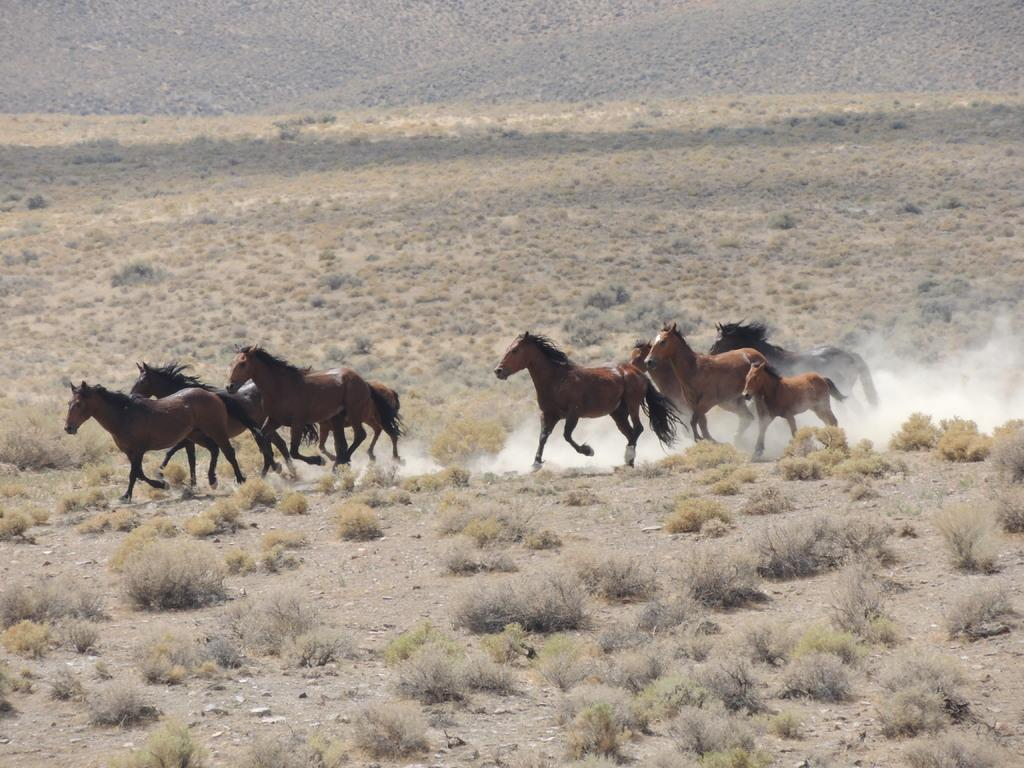What animals can be seen in the image? There are horses in the image. What are the horses doing in the image? The horses are running on the ground. What can be seen in the air due to the horses' movement? There is dust visible in the image. What type of vegetation is present on the ground in the image? There are plants on the ground in the image. Where is the glove located in the image? There is no glove present in the image. Can you describe the bridge in the image? There is no bridge present in the image. 